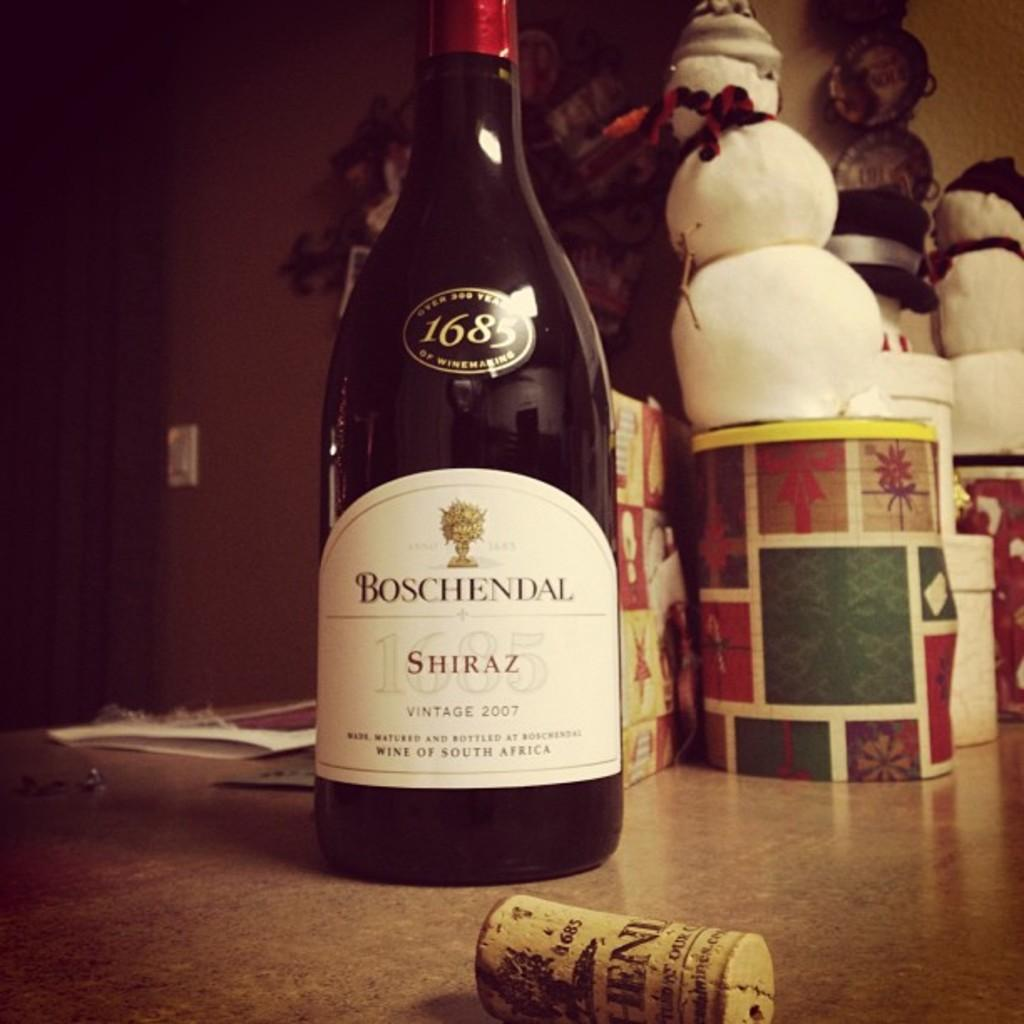What piece of furniture is present in the image? There is a table in the image. What is placed on the table? There is a beverage bottle, a cork, storage boxes, a toy snowman, and wall decors on the table. Can you describe the beverage bottle on the table? The beverage bottle is on the table, but its contents or brand cannot be determined from the image. What type of object is the cork? The cork is a small, round object, likely used to seal a container or bottle. Where is the hall located in the image? There is no hall present in the image; it features a table with various objects on it. What type of throne can be seen in the image? There is no throne present in the image; it features a table with various objects on it. 